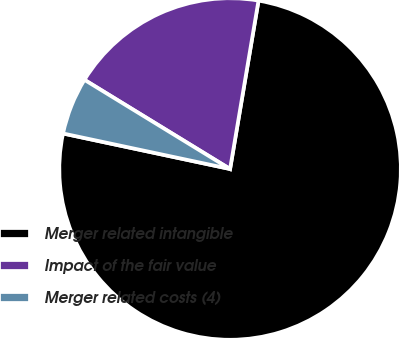Convert chart. <chart><loc_0><loc_0><loc_500><loc_500><pie_chart><fcel>Merger related intangible<fcel>Impact of the fair value<fcel>Merger related costs (4)<nl><fcel>75.68%<fcel>18.92%<fcel>5.41%<nl></chart> 